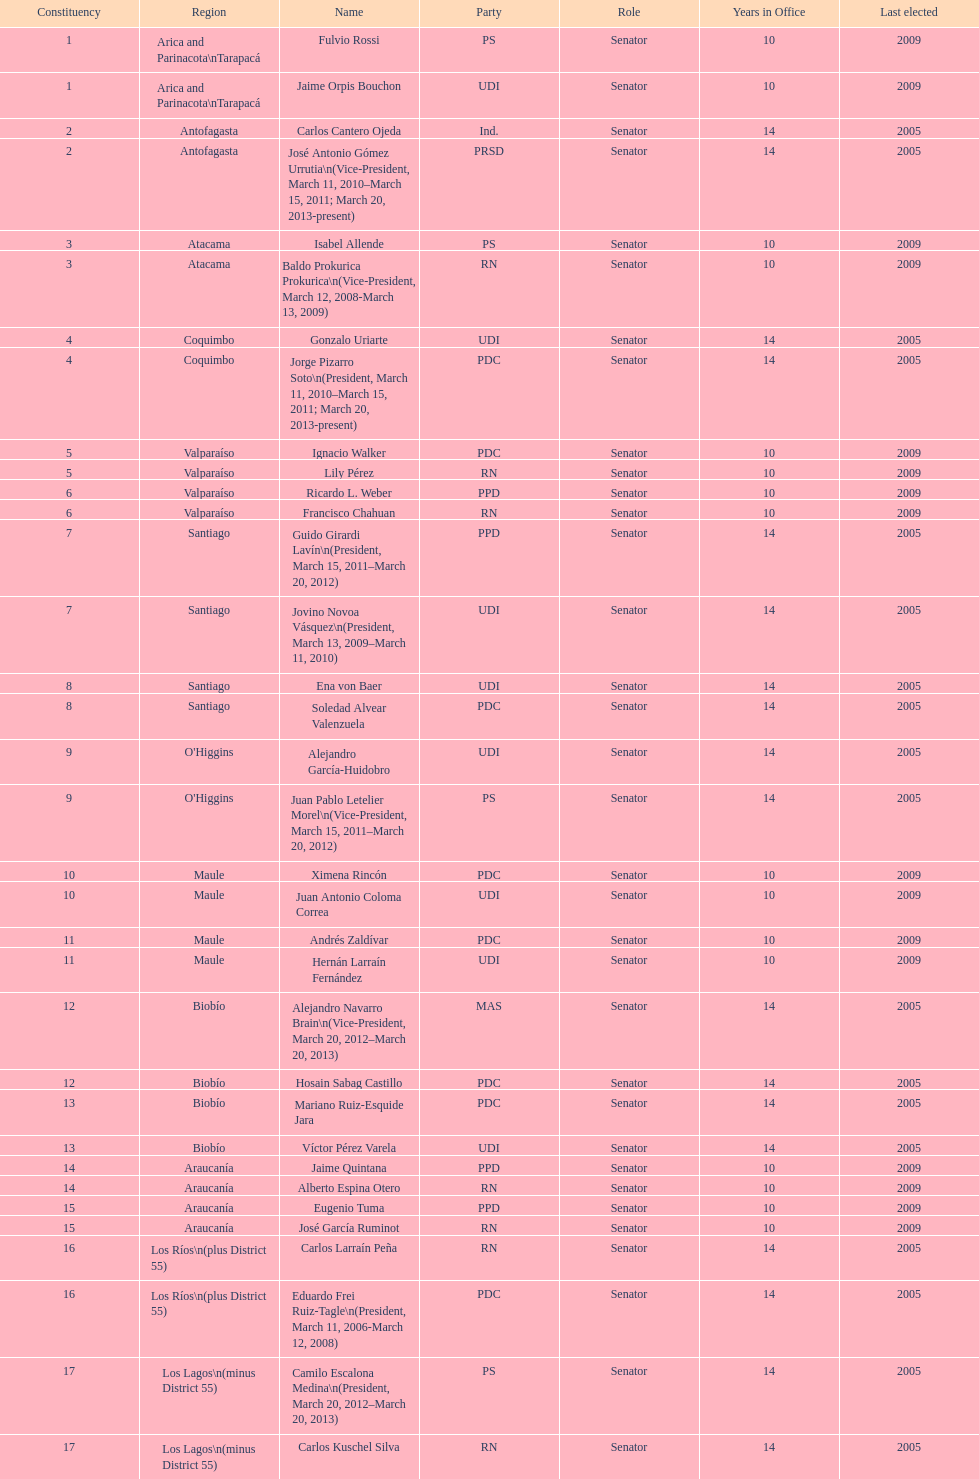When was antonio horvath kiss last elected? 2001. 